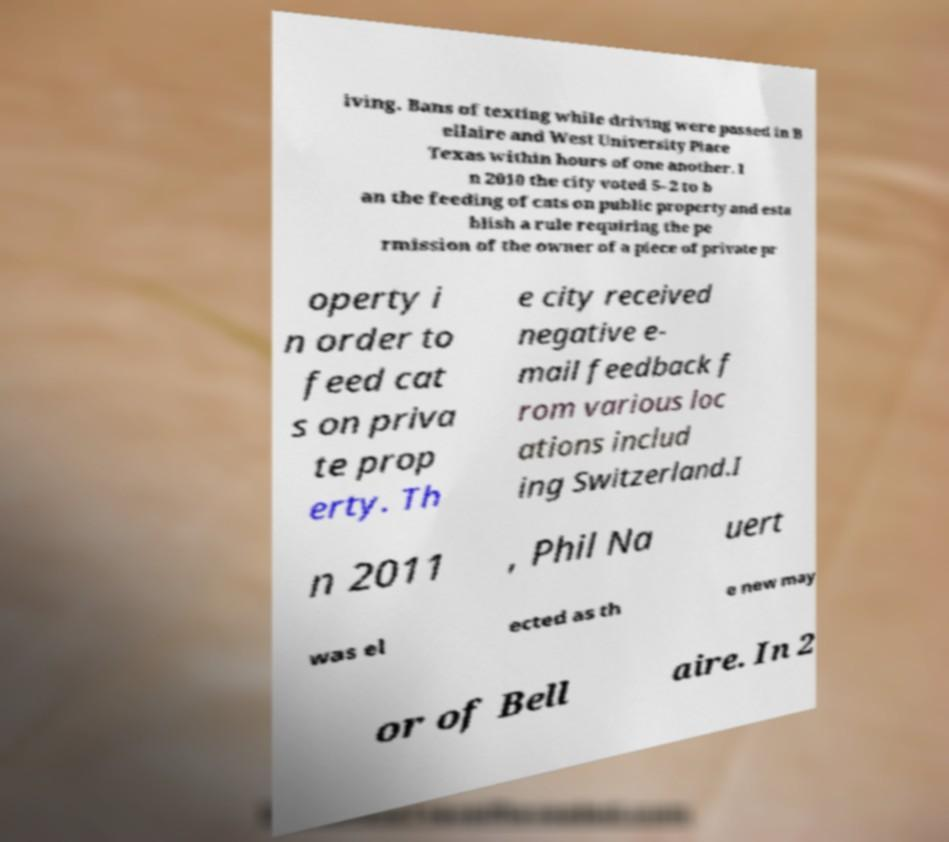Could you extract and type out the text from this image? iving. Bans of texting while driving were passed in B ellaire and West University Place Texas within hours of one another. I n 2010 the city voted 5–2 to b an the feeding of cats on public property and esta blish a rule requiring the pe rmission of the owner of a piece of private pr operty i n order to feed cat s on priva te prop erty. Th e city received negative e- mail feedback f rom various loc ations includ ing Switzerland.I n 2011 , Phil Na uert was el ected as th e new may or of Bell aire. In 2 